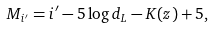<formula> <loc_0><loc_0><loc_500><loc_500>M _ { i ^ { \prime } } = i ^ { \prime } - 5 \log { d _ { L } } - K ( z ) + 5 ,</formula> 